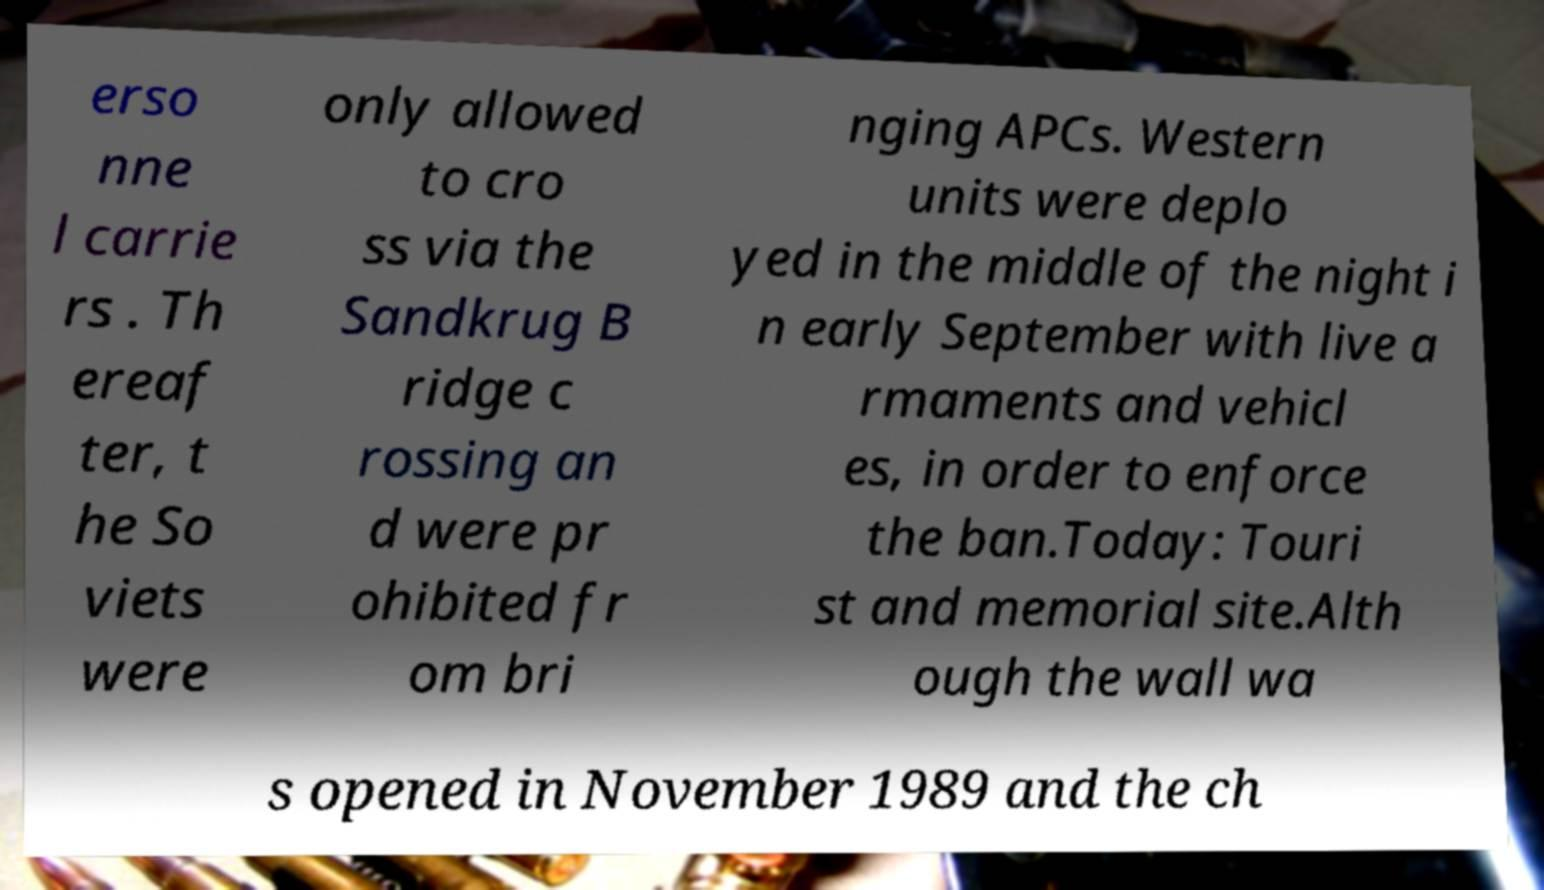Please identify and transcribe the text found in this image. erso nne l carrie rs . Th ereaf ter, t he So viets were only allowed to cro ss via the Sandkrug B ridge c rossing an d were pr ohibited fr om bri nging APCs. Western units were deplo yed in the middle of the night i n early September with live a rmaments and vehicl es, in order to enforce the ban.Today: Touri st and memorial site.Alth ough the wall wa s opened in November 1989 and the ch 